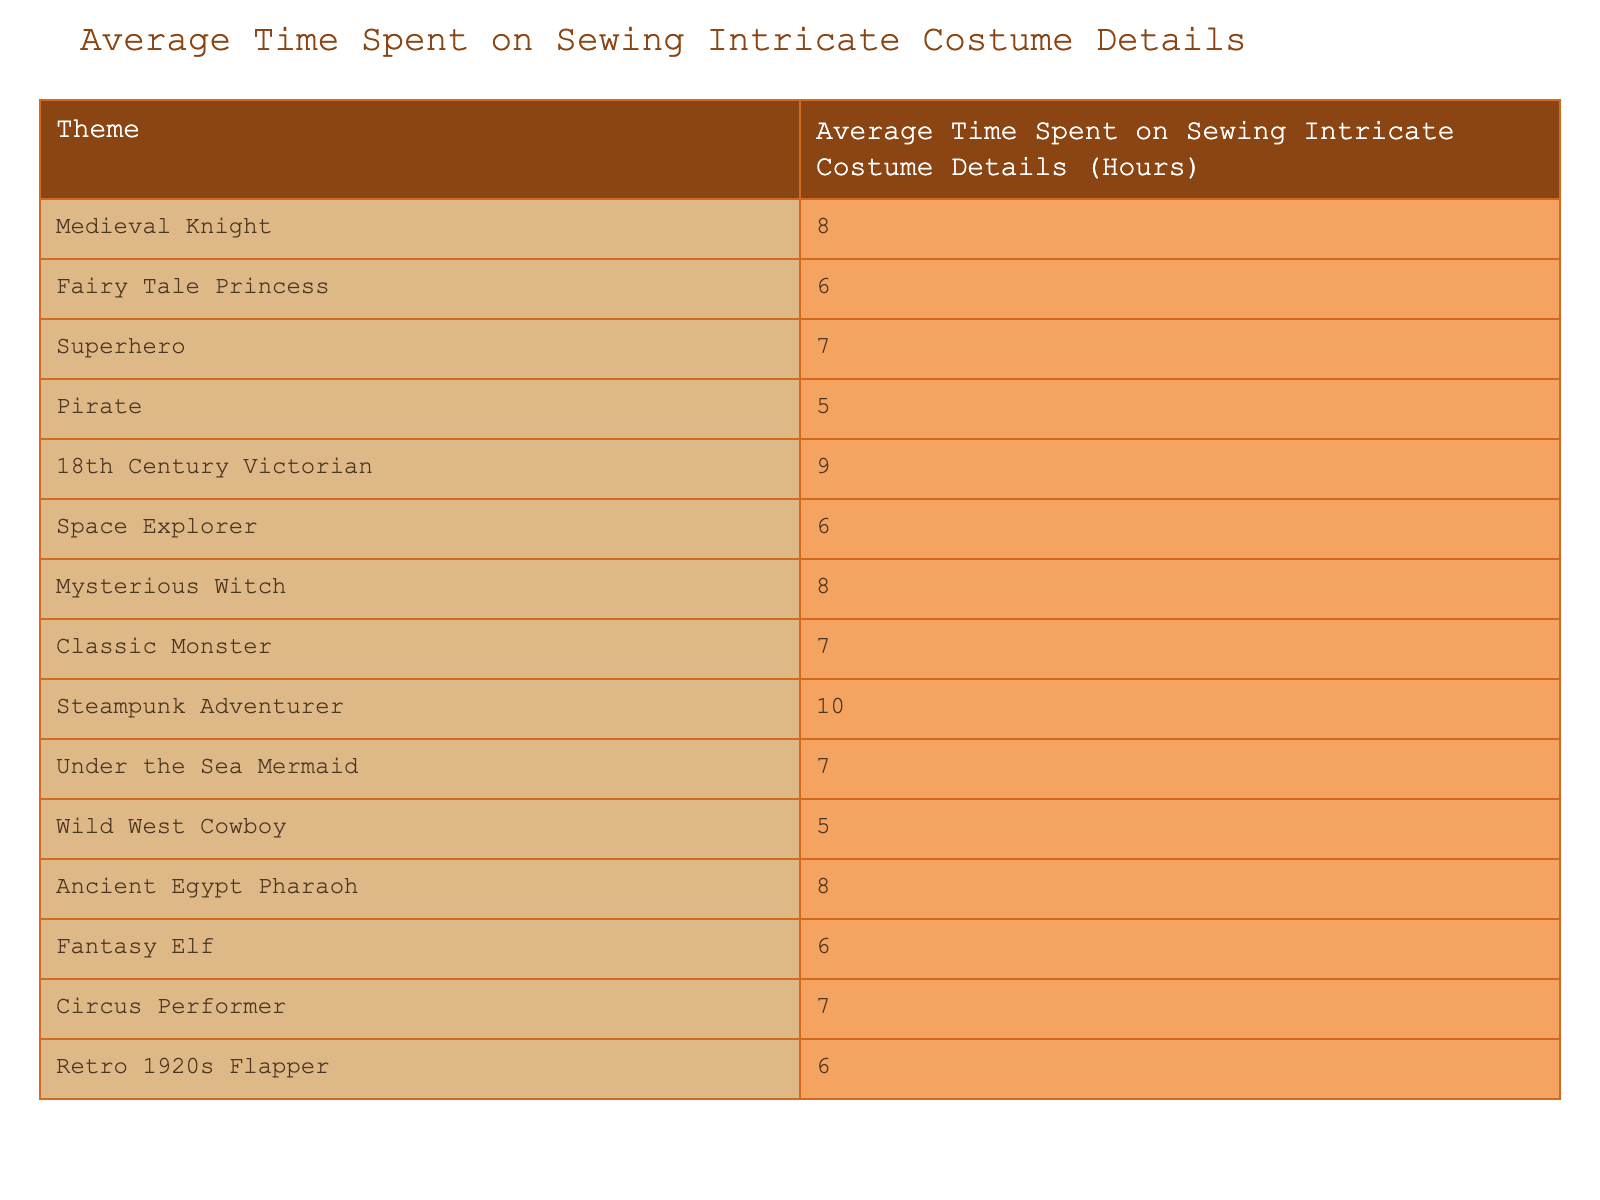What is the average time spent on sewing intricate costume details for a Steampunk Adventurer? According to the table, the average time spent on sewing intricate costume details for a Steampunk Adventurer is listed directly under that theme. The value is 10 hours.
Answer: 10 hours Which theme requires the least amount of time to sew intricate costume details? By examining the table, the themes "Pirate" and "Wild West Cowboy" both have the lowest average time of 5 hours. After checking all entries, these are the minimum values, making it a tie.
Answer: Pirate and Wild West Cowboy (5 hours) What is the time difference between sewing details for the Medieval Knight and the 18th Century Victorian themes? The average time for Medieval Knight is 8 hours and for 18th Century Victorian is 9 hours. The difference is calculated as 9 - 8 = 1 hour, showing that the 18th Century Victorian takes 1 hour more.
Answer: 1 hour Is the average time spent on sewing details for a Superhero theme greater than that for a Fantasy Elf theme? The table shows that the average time for a Superhero is 7 hours, while for a Fantasy Elf, it is 6 hours. Since 7 is greater than 6, the statement is true.
Answer: Yes If a Circus Performer is sewn with the same level of detail as a Mysterious Witch, how much total time would be spent? The table indicates that the average time for Circus Performer is 7 hours and for Mysterious Witch is 8 hours. Adding these together gives 7 + 8 = 15 hours for both.
Answer: 15 hours What is the average of the sewing times for the Medieval Knight, Mysterious Witch, and Ancient Egypt Pharaoh themes? The sewing times for these themes are 8, 8, and 8 hours, respectively. To find the average, sum: 8 + 8 + 8 = 24, then divide by the number of themes (3) to get 24 / 3 = 8 hours.
Answer: 8 hours Which theme has the same average sewing time as the Fairy Tale Princess? The table shows that the average time for Fairy Tale Princess is 6 hours. Looking for other themes with this value, we find Space Explorer, Fantasy Elf, and Retro 1920s Flapper also have average times of 6 hours.
Answer: Space Explorer, Fantasy Elf, Retro 1920s Flapper Is it true that all themes related to historical periods require more than 6 hours on average? From the table, "18th Century Victorian" is 9 hours and "Ancient Egypt Pharaoh" is 8 hours, both are over 6. However, "Pirate" and "Wild West Cowboy" are both 5 hours, which are below that mark. Therefore, the statement is false.
Answer: No How much combined time would be spent on sewing details for a Pirate and a Wild West Cowboy theme? The average time for Pirate is 5 hours and for Wild West Cowboy is also 5 hours. Adding these times together yields 5 + 5 = 10 hours spent on both themes.
Answer: 10 hours If a designer chose to combine the Superhero and Under the Sea Mermaid themes, what would be the average time spent on both? The average times are 7 hours for Superhero and 7 hours for Under the Sea Mermaid. Since they are the same, the average remains 7 hours.
Answer: 7 hours 